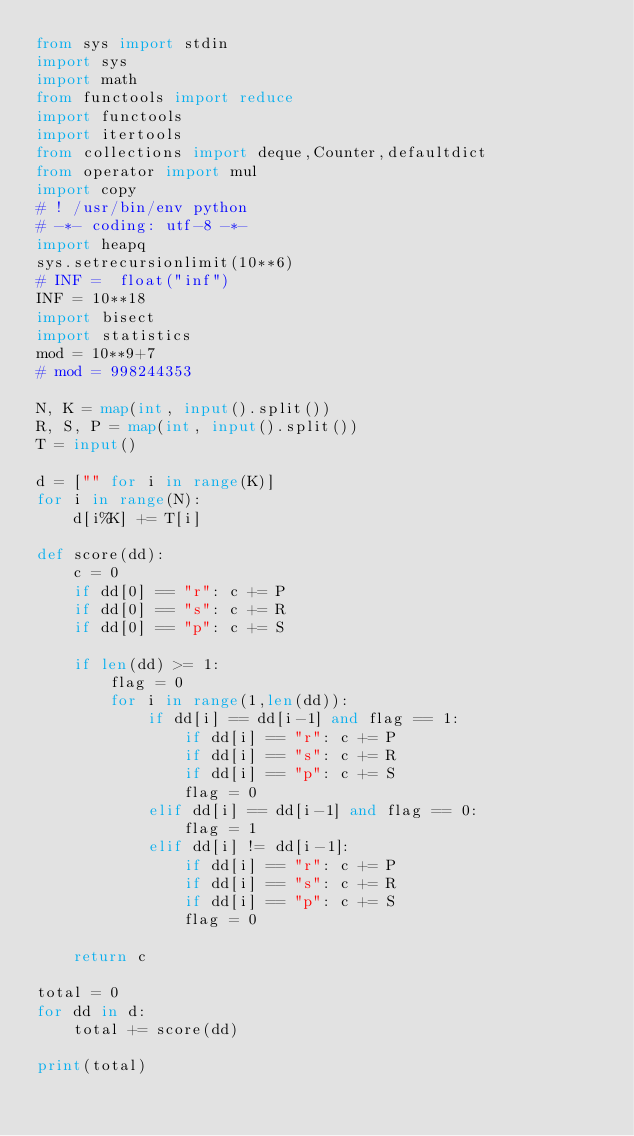<code> <loc_0><loc_0><loc_500><loc_500><_Python_>from sys import stdin
import sys
import math
from functools import reduce
import functools
import itertools
from collections import deque,Counter,defaultdict
from operator import mul
import copy
# ! /usr/bin/env python
# -*- coding: utf-8 -*-
import heapq
sys.setrecursionlimit(10**6)
# INF =  float("inf")
INF = 10**18
import bisect
import statistics
mod = 10**9+7
# mod = 998244353

N, K = map(int, input().split())
R, S, P = map(int, input().split())
T = input()

d = ["" for i in range(K)]
for i in range(N):
    d[i%K] += T[i]

def score(dd):
    c = 0
    if dd[0] == "r": c += P
    if dd[0] == "s": c += R
    if dd[0] == "p": c += S

    if len(dd) >= 1:
        flag = 0
        for i in range(1,len(dd)):
            if dd[i] == dd[i-1] and flag == 1:
                if dd[i] == "r": c += P
                if dd[i] == "s": c += R
                if dd[i] == "p": c += S
                flag = 0
            elif dd[i] == dd[i-1] and flag == 0:
                flag = 1
            elif dd[i] != dd[i-1]:
                if dd[i] == "r": c += P
                if dd[i] == "s": c += R
                if dd[i] == "p": c += S
                flag = 0

    return c

total = 0
for dd in d:
    total += score(dd)

print(total)
</code> 